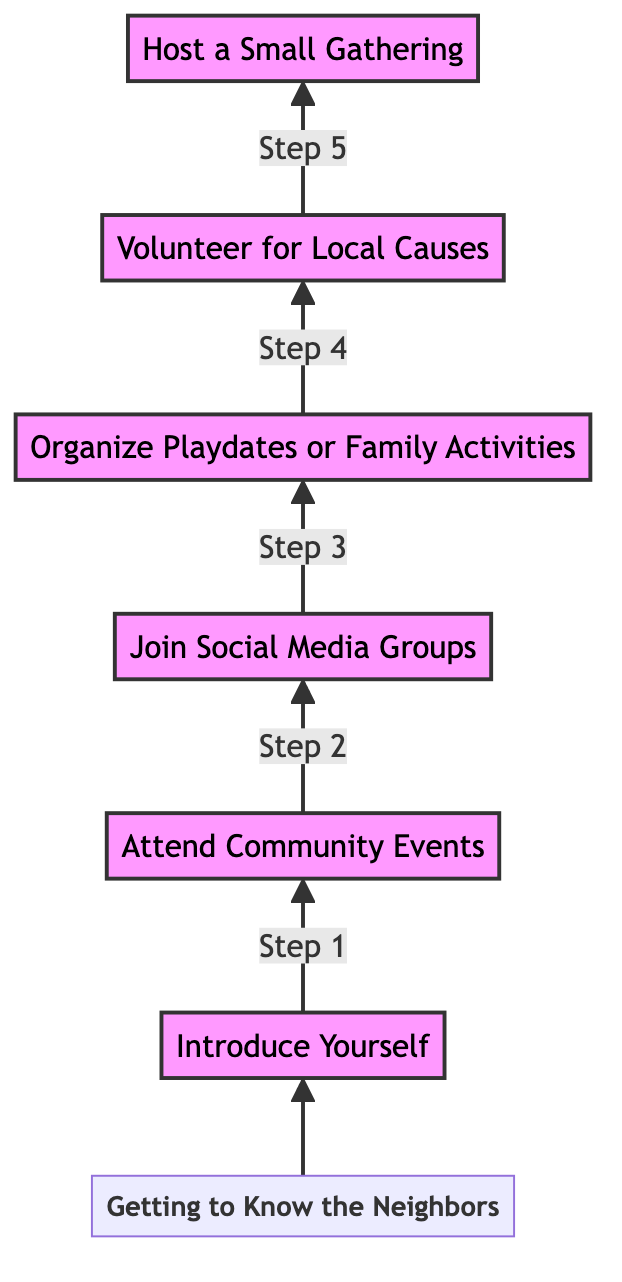What is the first step to get to know your neighbors? The first step specified in the diagram is "Introduce Yourself." This is indicated as the very first node at level 1.
Answer: Introduce Yourself How many total steps are there to know the neighbors? The diagram outlines a total of 6 steps, represented by the 6 nodes from "Introduce Yourself" to "Host a Small Gathering."
Answer: 6 Which step follows "Join Social Media Groups"? The step that follows "Join Social Media Groups," which is at level 3, is "Organize Playdates or Family Activities," positioned directly above it at level 4.
Answer: Organize Playdates or Family Activities What action is suggested after "Attend Community Events"? The action that comes directly after "Attend Community Events" at level 2 is "Join Social Media Groups," which can help extend connections made at events.
Answer: Join Social Media Groups Which step is the highest in the flowchart? The highest step in the flowchart is "Host a Small Gathering," represented at level 6. This is the final action in the sequence, showing it as the culmination of efforts.
Answer: Host a Small Gathering What is the connection between "Volunteer for Local Causes" and "Host a Small Gathering"? "Volunteer for Local Causes" is a step that leads to "Host a Small Gathering," indicating that volunteering can help build relationships which may be celebrated in a gathering afterward.
Answer: Leads to Which step has the lowest number in the flow? The step with the lowest number in the flow is "Introduce Yourself," which is the starting point of the sequence. It has the highest level of importance as the initiating action.
Answer: Introduce Yourself What type of events can help you meet more neighbors according to the diagram? The diagram suggests attending local gatherings, such as block parties, garage sales, and town fairs, as events to meet new people.
Answer: Community Events What is the purpose of "Organize Playdates or Family Activities"? The purpose of this step is to foster connections among families and further know your neighbors through shared activities, specifically for kids and family engagement.
Answer: Foster connections 